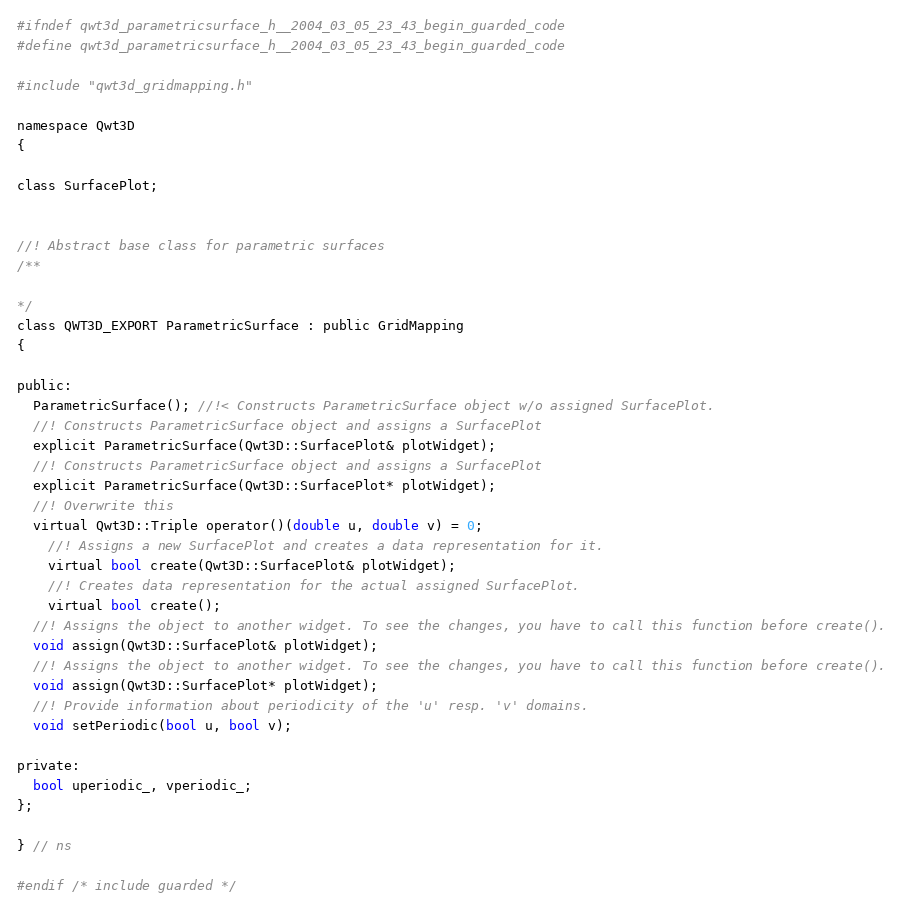<code> <loc_0><loc_0><loc_500><loc_500><_C_>#ifndef qwt3d_parametricsurface_h__2004_03_05_23_43_begin_guarded_code
#define qwt3d_parametricsurface_h__2004_03_05_23_43_begin_guarded_code

#include "qwt3d_gridmapping.h"

namespace Qwt3D
{

class SurfacePlot;


//! Abstract base class for parametric surfaces
/**

*/
class QWT3D_EXPORT ParametricSurface : public GridMapping
{

public:
  ParametricSurface(); //!< Constructs ParametricSurface object w/o assigned SurfacePlot.
  //! Constructs ParametricSurface object and assigns a SurfacePlot
  explicit ParametricSurface(Qwt3D::SurfacePlot& plotWidget); 
  //! Constructs ParametricSurface object and assigns a SurfacePlot
  explicit ParametricSurface(Qwt3D::SurfacePlot* plotWidget); 
  //! Overwrite this
  virtual Qwt3D::Triple operator()(double u, double v) = 0; 
	//! Assigns a new SurfacePlot and creates a data representation for it.
	virtual bool create(Qwt3D::SurfacePlot& plotWidget);
	//! Creates data representation for the actual assigned SurfacePlot.
	virtual bool create();
  //! Assigns the object to another widget. To see the changes, you have to call this function before create().
  void assign(Qwt3D::SurfacePlot& plotWidget);
  //! Assigns the object to another widget. To see the changes, you have to call this function before create().
  void assign(Qwt3D::SurfacePlot* plotWidget);
  //! Provide information about periodicity of the 'u' resp. 'v' domains.
  void setPeriodic(bool u, bool v); 

private:
  bool uperiodic_, vperiodic_;
};

} // ns

#endif /* include guarded */
</code> 